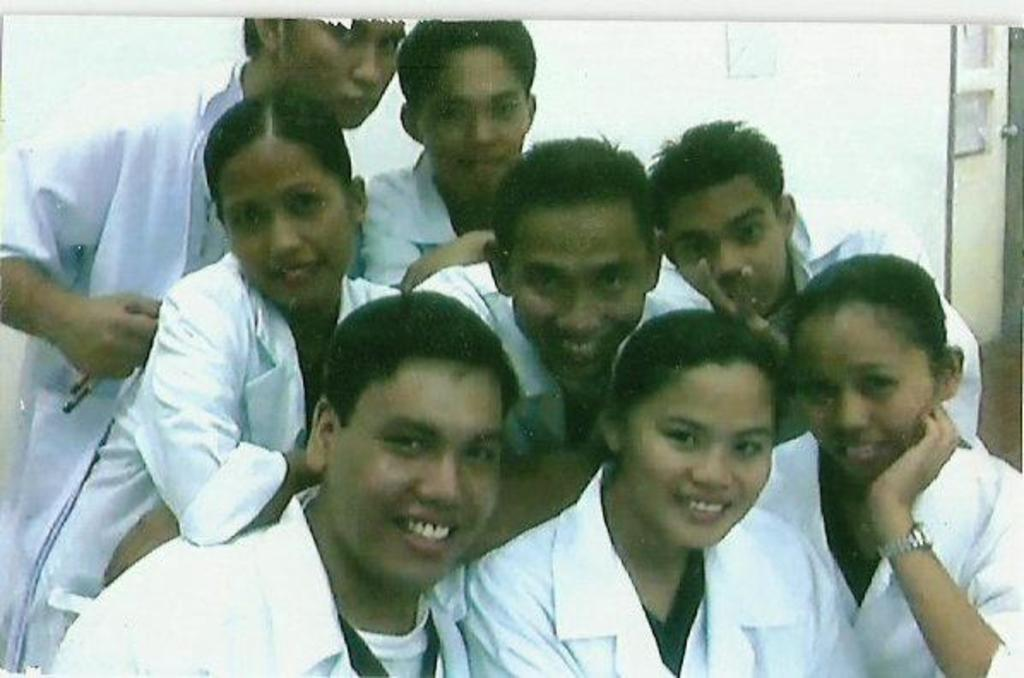Who or what can be seen in the image? There are people in the image. What are the people wearing? The people are wearing white color aprons. What can be seen in the background of the image? There is a wall in the image. Is there any entrance or exit visible in the image? Yes, there is a door in the image. What type of throne can be seen in the image? There is no throne present in the image. What is being served for breakfast in the image? The image does not depict any food or meal, so it cannot be determined what is being served for breakfast. 